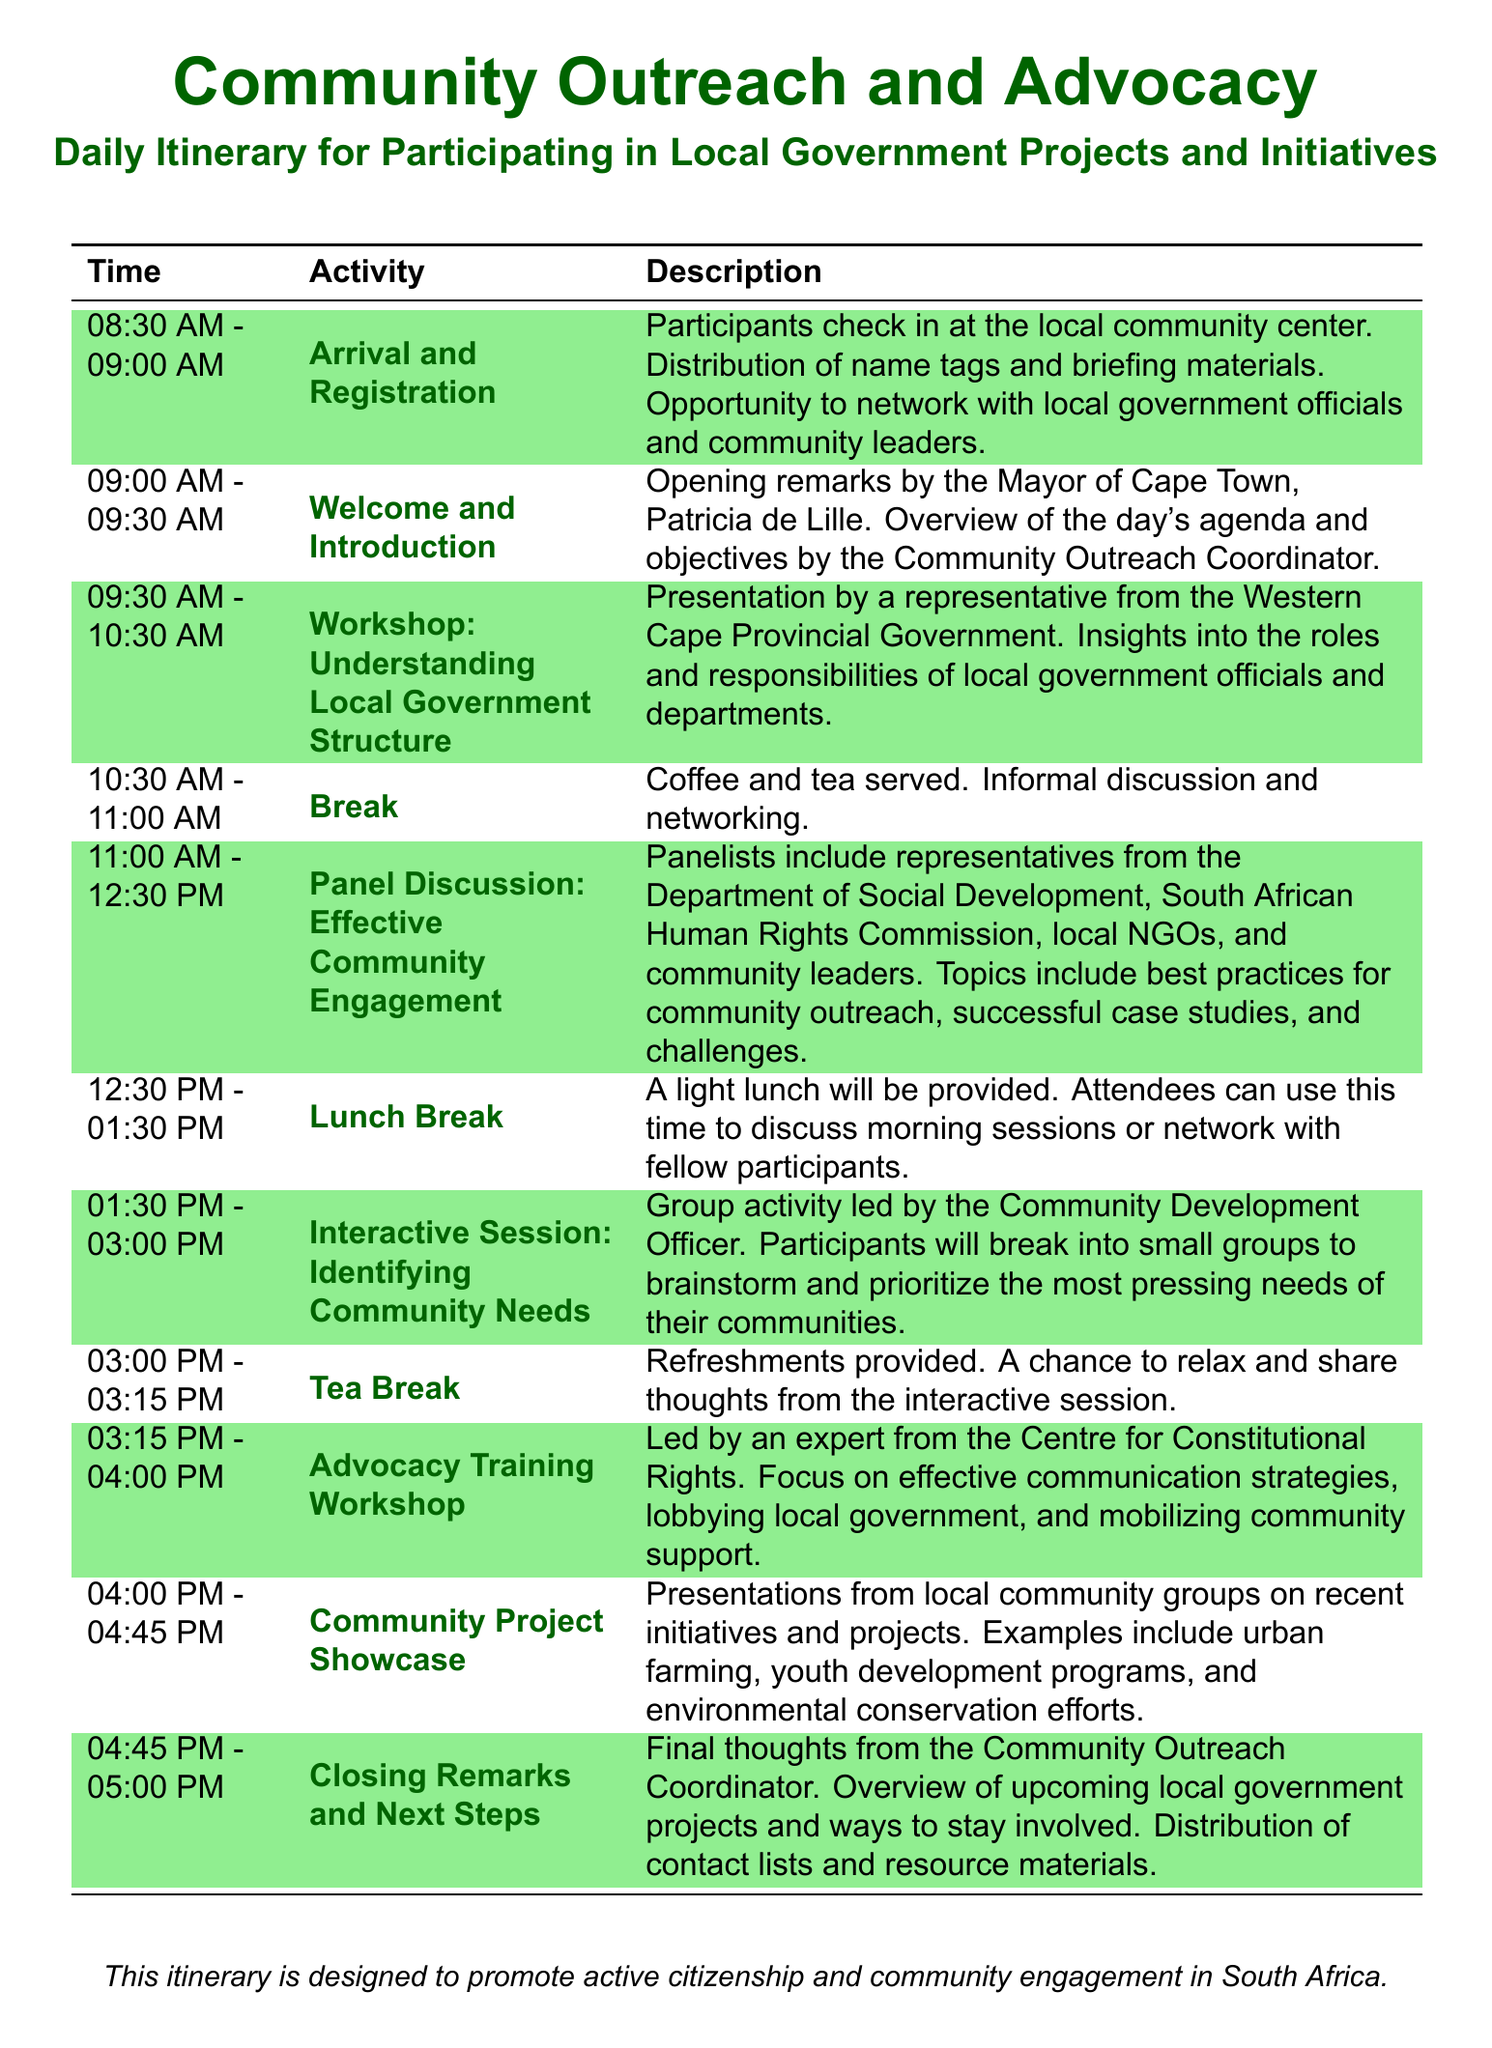What time does the day start? The day's activities begin at 08:30 AM with Arrival and Registration.
Answer: 08:30 AM Who gives the opening remarks? The opening remarks are delivered by the Mayor of Cape Town, Patricia de Lille.
Answer: Patricia de Lille What is the duration of the Advocacy Training Workshop? The Advocacy Training Workshop lasts for 45 minutes, from 03:15 PM to 04:00 PM.
Answer: 45 minutes What is the focus of the Interactive Session? The focus of the Interactive Session is to identify and prioritize community needs.
Answer: Identifying Community Needs Which panelists are included in the discussion on effective community engagement? The panelists include representatives from the Department of Social Development, South African Human Rights Commission, local NGOs, and community leaders.
Answer: Local NGOs How long is the lunch break? The lunch break lasts for one hour from 12:30 PM to 01:30 PM.
Answer: One hour What activity occurs immediately after the tea break? The activity following the tea break is the Advocacy Training Workshop.
Answer: Advocacy Training Workshop What type of projects are showcased during the Community Project Showcase? The types of projects include urban farming, youth development programs, and environmental conservation efforts.
Answer: Urban farming What are attendees provided with during registration? During registration, participants receive name tags and briefing materials.
Answer: Name tags and briefing materials 